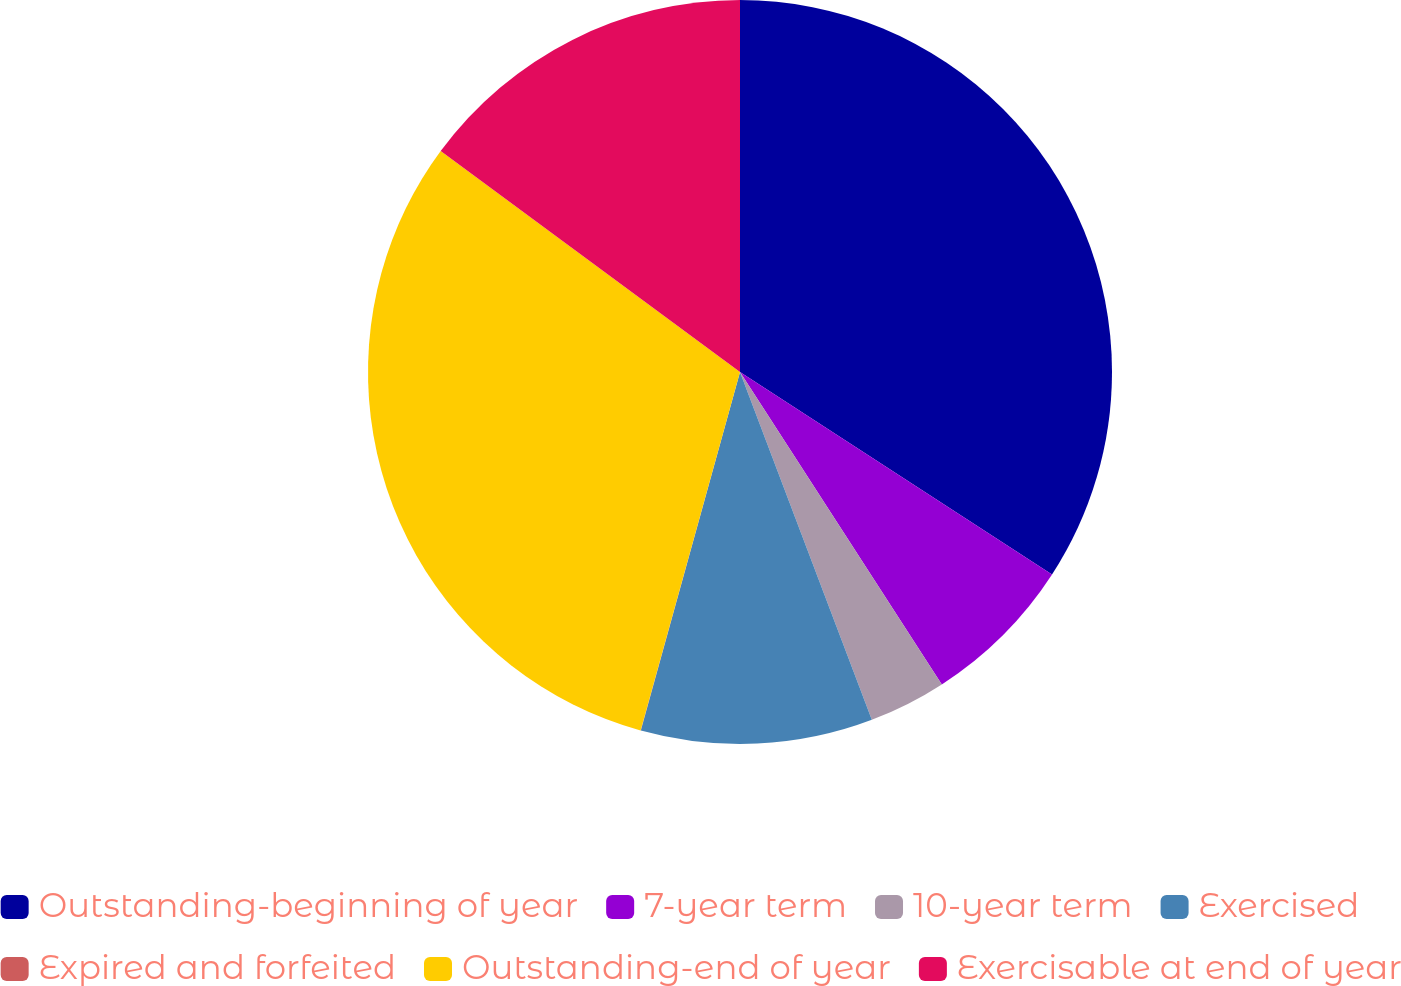Convert chart. <chart><loc_0><loc_0><loc_500><loc_500><pie_chart><fcel>Outstanding-beginning of year<fcel>7-year term<fcel>10-year term<fcel>Exercised<fcel>Expired and forfeited<fcel>Outstanding-end of year<fcel>Exercisable at end of year<nl><fcel>34.16%<fcel>6.71%<fcel>3.36%<fcel>10.06%<fcel>0.01%<fcel>30.81%<fcel>14.88%<nl></chart> 